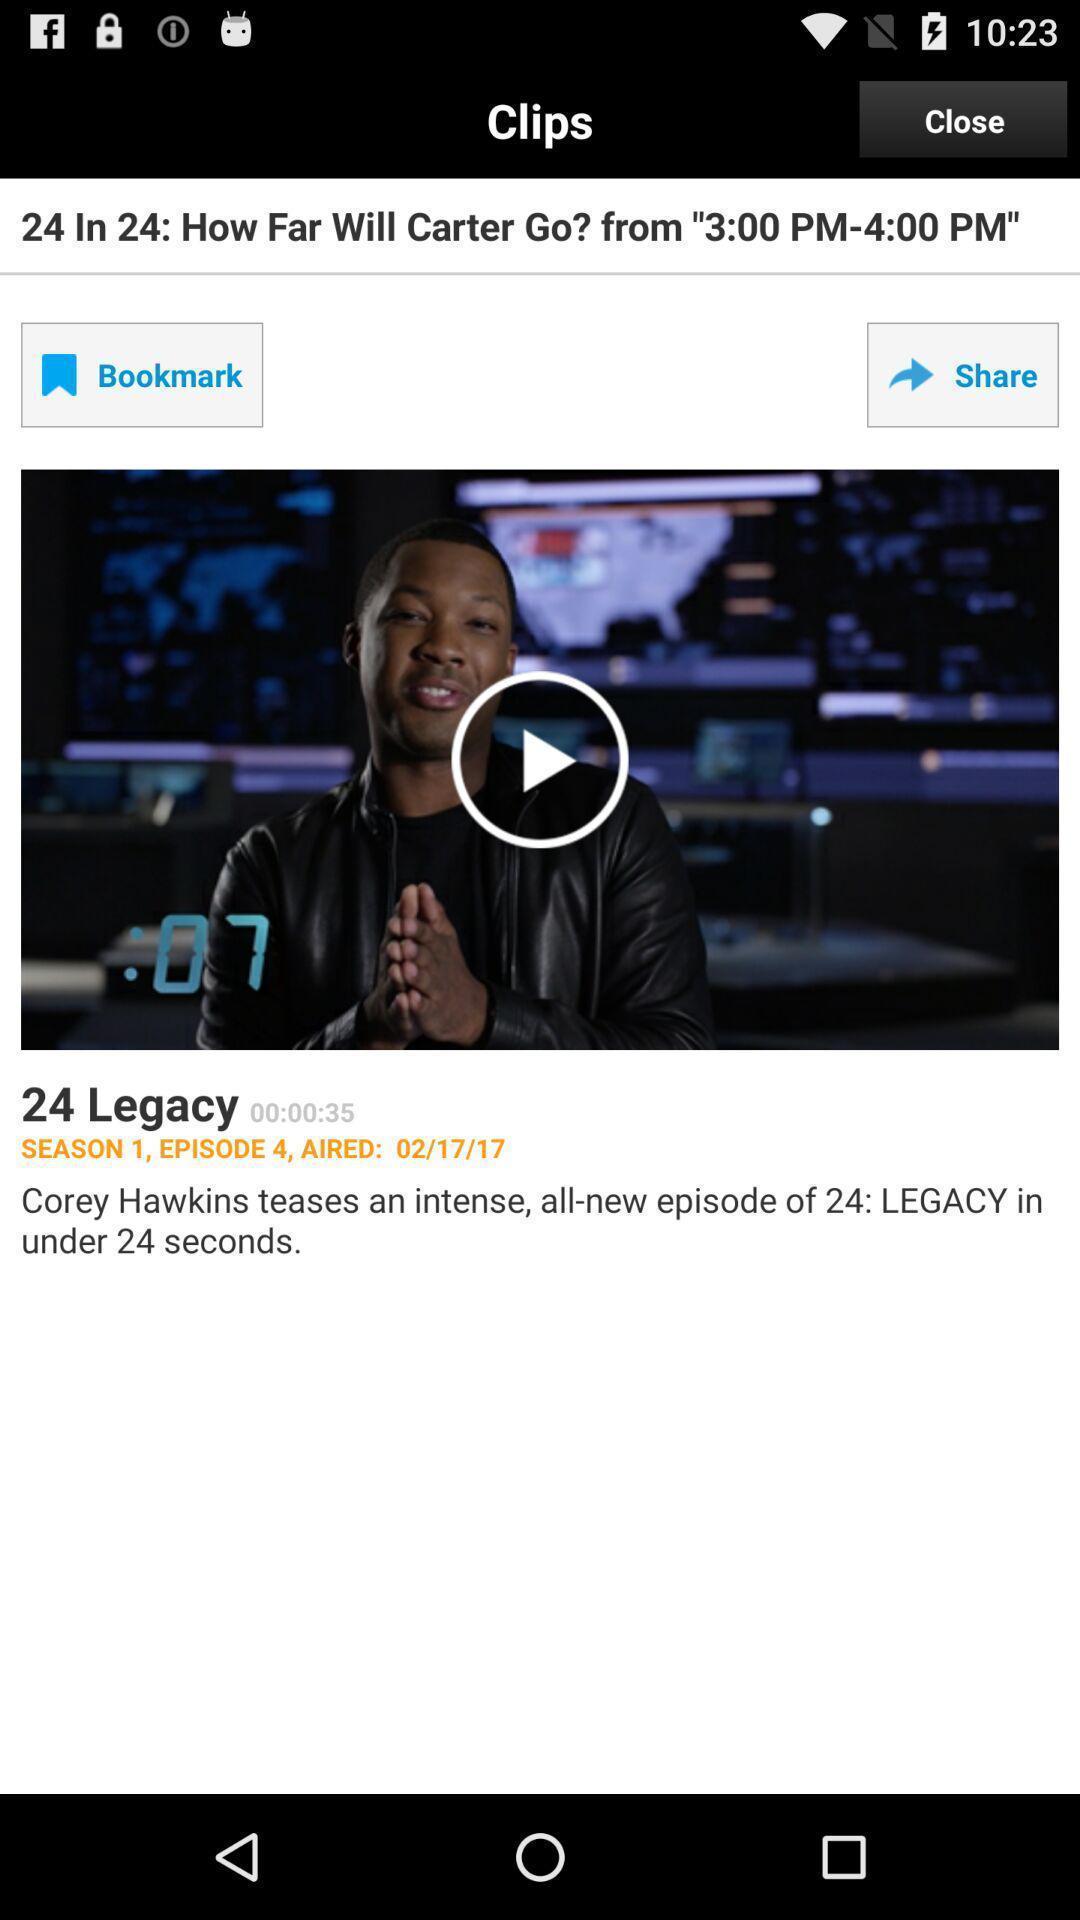Provide a description of this screenshot. Video clips in the application with some options. 